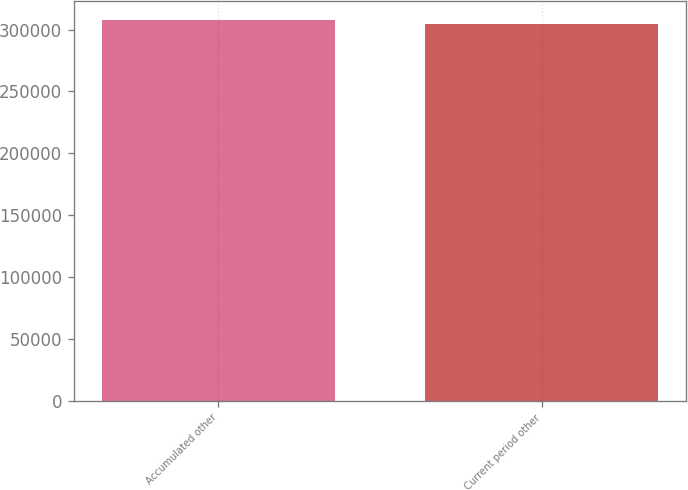Convert chart to OTSL. <chart><loc_0><loc_0><loc_500><loc_500><bar_chart><fcel>Accumulated other<fcel>Current period other<nl><fcel>307618<fcel>304684<nl></chart> 